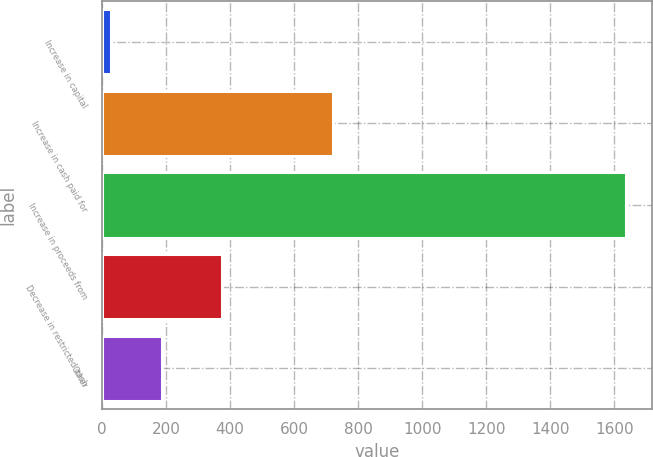Convert chart. <chart><loc_0><loc_0><loc_500><loc_500><bar_chart><fcel>Increase in capital<fcel>Increase in cash paid for<fcel>Increase in proceeds from<fcel>Decrease in restricted cash<fcel>Other<nl><fcel>28<fcel>721<fcel>1637<fcel>375<fcel>188.9<nl></chart> 